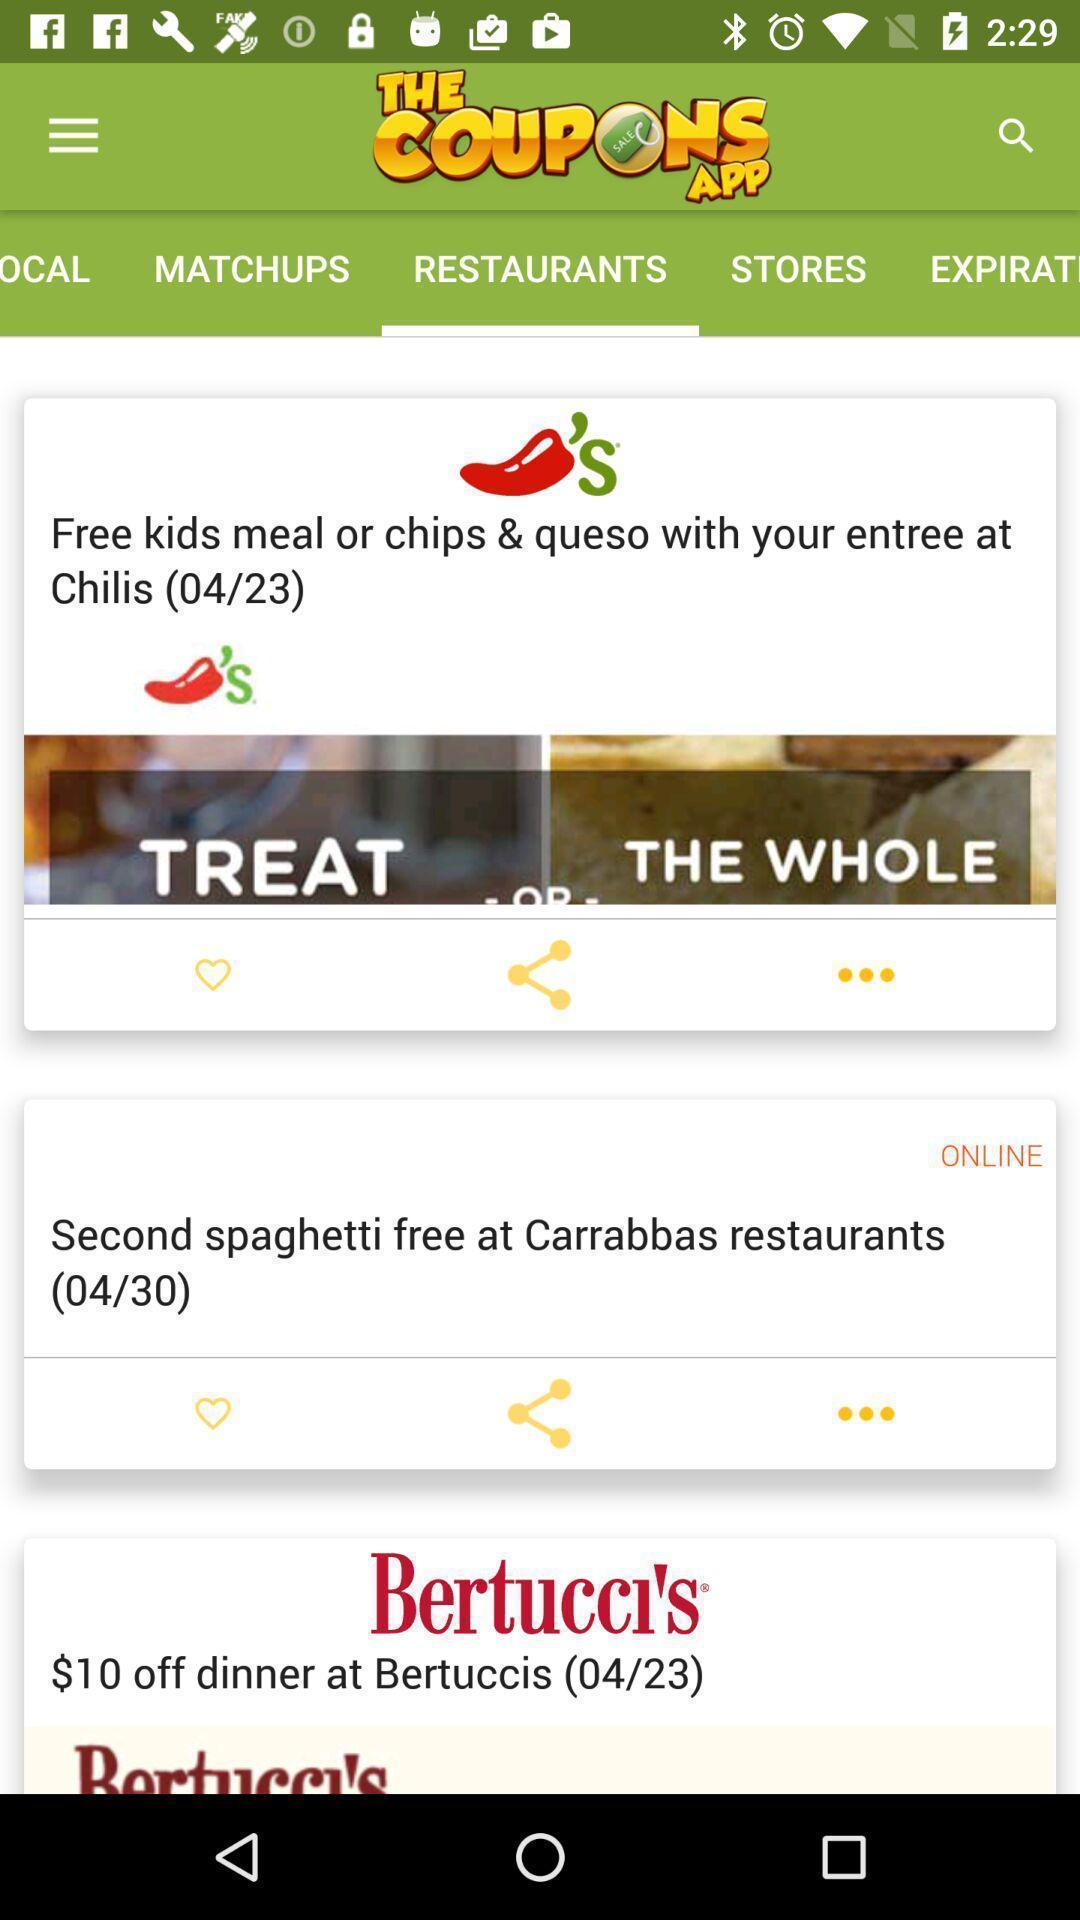Explain the elements present in this screenshot. Page displays restaurants list in app. 